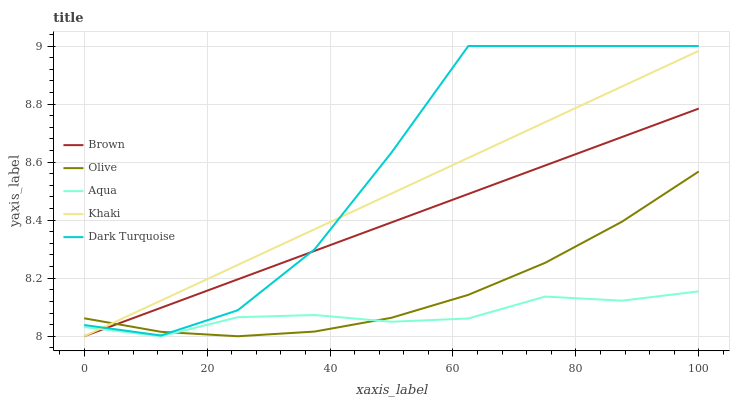Does Aqua have the minimum area under the curve?
Answer yes or no. Yes. Does Dark Turquoise have the maximum area under the curve?
Answer yes or no. Yes. Does Brown have the minimum area under the curve?
Answer yes or no. No. Does Brown have the maximum area under the curve?
Answer yes or no. No. Is Brown the smoothest?
Answer yes or no. Yes. Is Dark Turquoise the roughest?
Answer yes or no. Yes. Is Aqua the smoothest?
Answer yes or no. No. Is Aqua the roughest?
Answer yes or no. No. Does Brown have the lowest value?
Answer yes or no. Yes. Does Dark Turquoise have the lowest value?
Answer yes or no. No. Does Dark Turquoise have the highest value?
Answer yes or no. Yes. Does Brown have the highest value?
Answer yes or no. No. Is Aqua less than Dark Turquoise?
Answer yes or no. Yes. Is Dark Turquoise greater than Aqua?
Answer yes or no. Yes. Does Khaki intersect Aqua?
Answer yes or no. Yes. Is Khaki less than Aqua?
Answer yes or no. No. Is Khaki greater than Aqua?
Answer yes or no. No. Does Aqua intersect Dark Turquoise?
Answer yes or no. No. 